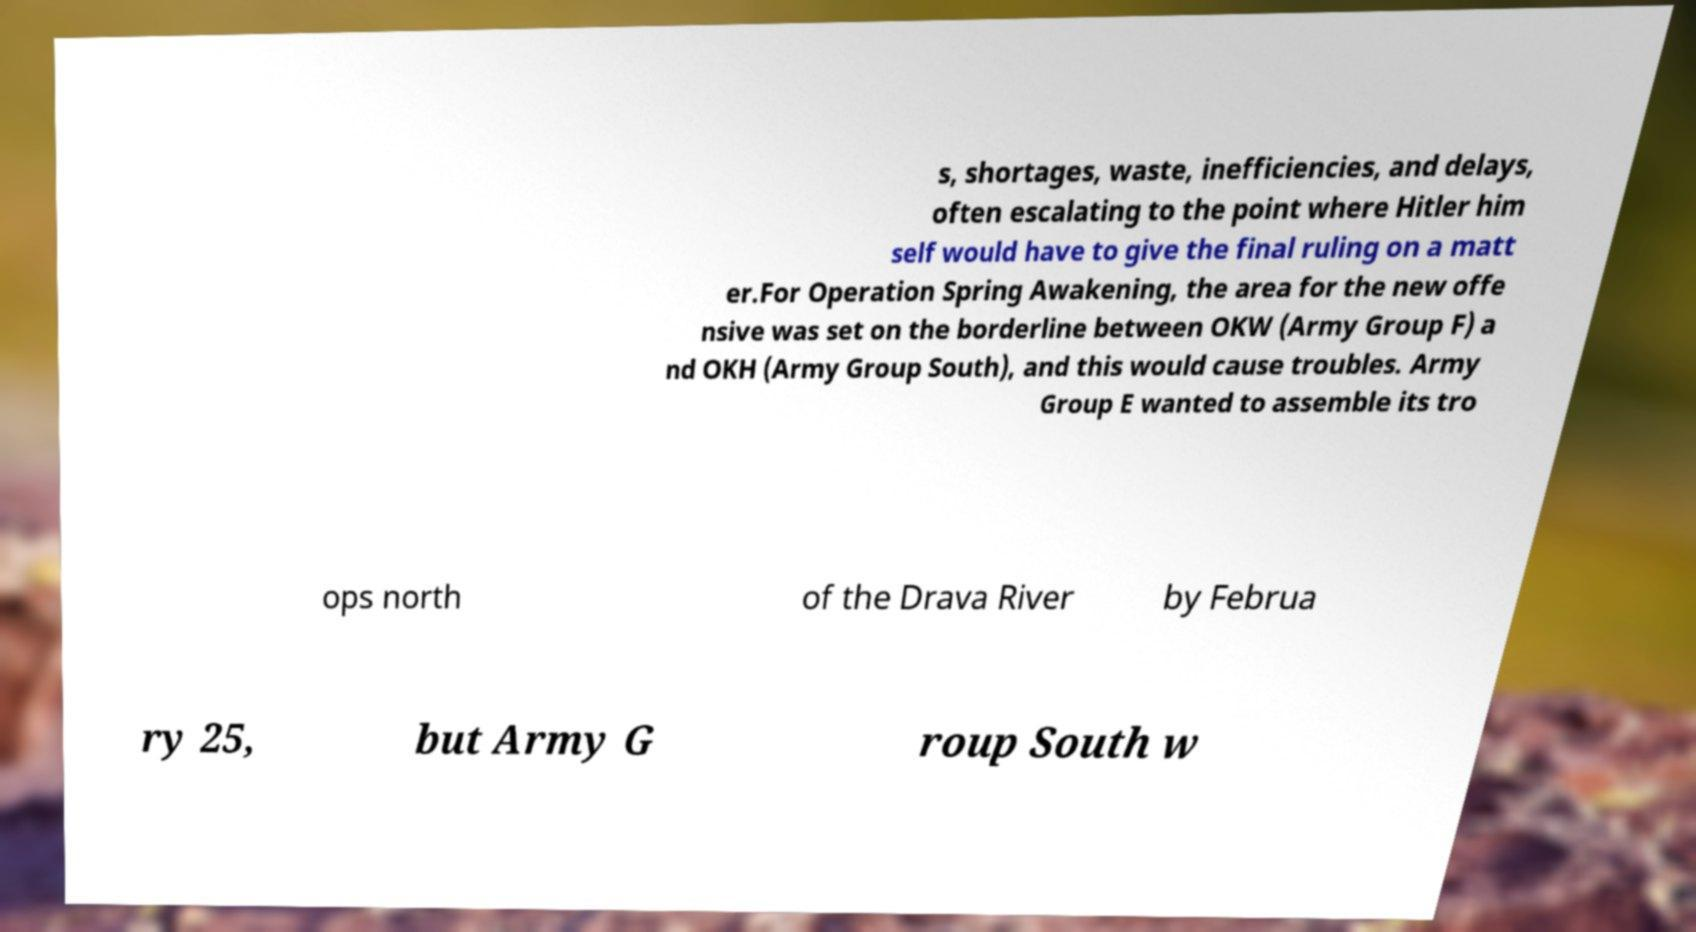There's text embedded in this image that I need extracted. Can you transcribe it verbatim? s, shortages, waste, inefficiencies, and delays, often escalating to the point where Hitler him self would have to give the final ruling on a matt er.For Operation Spring Awakening, the area for the new offe nsive was set on the borderline between OKW (Army Group F) a nd OKH (Army Group South), and this would cause troubles. Army Group E wanted to assemble its tro ops north of the Drava River by Februa ry 25, but Army G roup South w 